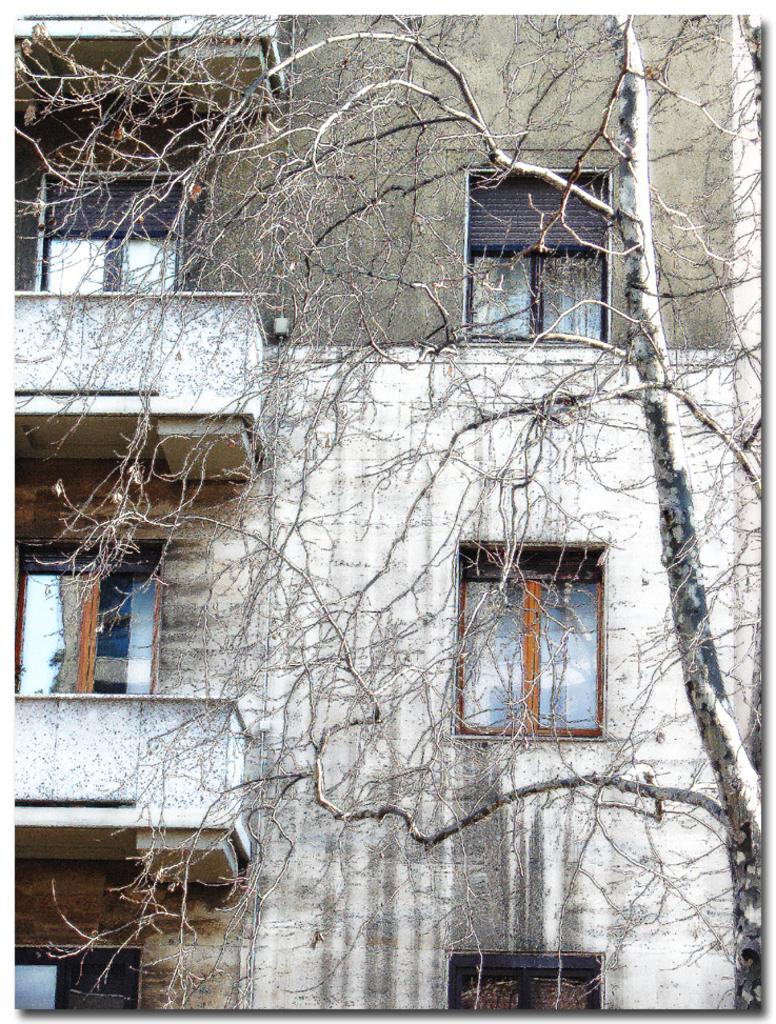What is the condition of the tree in the image? The tree in the image is dry. What can be seen behind the tree in the image? There is a building visible behind the tree. Can you describe the appearance of the building? The building appears old. Is there a pocket watch hanging from the tree in the image? No, there is no pocket watch or any other object hanging from the tree in the image. 